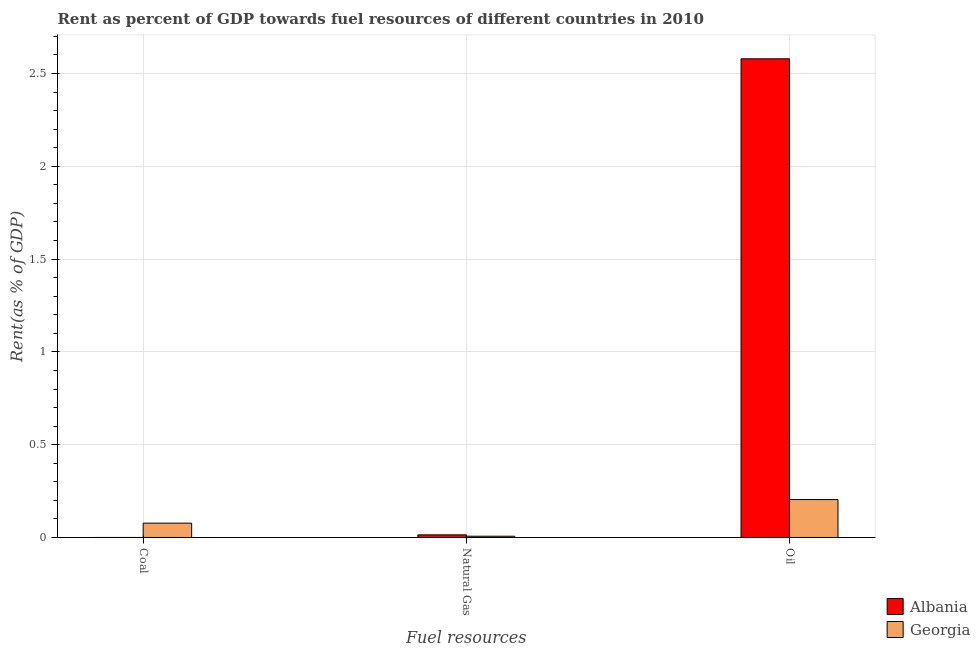How many different coloured bars are there?
Your answer should be very brief. 2. How many groups of bars are there?
Keep it short and to the point. 3. Are the number of bars per tick equal to the number of legend labels?
Your answer should be compact. Yes. Are the number of bars on each tick of the X-axis equal?
Provide a short and direct response. Yes. What is the label of the 1st group of bars from the left?
Offer a terse response. Coal. What is the rent towards oil in Albania?
Provide a succinct answer. 2.58. Across all countries, what is the maximum rent towards natural gas?
Make the answer very short. 0.01. Across all countries, what is the minimum rent towards coal?
Keep it short and to the point. 0. In which country was the rent towards coal maximum?
Offer a very short reply. Georgia. In which country was the rent towards natural gas minimum?
Give a very brief answer. Georgia. What is the total rent towards coal in the graph?
Ensure brevity in your answer.  0.08. What is the difference between the rent towards natural gas in Georgia and that in Albania?
Offer a very short reply. -0.01. What is the difference between the rent towards natural gas in Georgia and the rent towards oil in Albania?
Give a very brief answer. -2.57. What is the average rent towards oil per country?
Give a very brief answer. 1.39. What is the difference between the rent towards oil and rent towards natural gas in Albania?
Offer a terse response. 2.56. In how many countries, is the rent towards coal greater than 2.4 %?
Offer a very short reply. 0. What is the ratio of the rent towards coal in Albania to that in Georgia?
Give a very brief answer. 0. What is the difference between the highest and the second highest rent towards oil?
Keep it short and to the point. 2.37. What is the difference between the highest and the lowest rent towards oil?
Ensure brevity in your answer.  2.37. Is the sum of the rent towards oil in Albania and Georgia greater than the maximum rent towards natural gas across all countries?
Your answer should be very brief. Yes. What does the 2nd bar from the left in Natural Gas represents?
Keep it short and to the point. Georgia. What does the 1st bar from the right in Natural Gas represents?
Keep it short and to the point. Georgia. Is it the case that in every country, the sum of the rent towards coal and rent towards natural gas is greater than the rent towards oil?
Make the answer very short. No. How many bars are there?
Make the answer very short. 6. How many countries are there in the graph?
Your response must be concise. 2. What is the difference between two consecutive major ticks on the Y-axis?
Provide a succinct answer. 0.5. Are the values on the major ticks of Y-axis written in scientific E-notation?
Your response must be concise. No. Does the graph contain any zero values?
Offer a very short reply. No. Does the graph contain grids?
Provide a short and direct response. Yes. How are the legend labels stacked?
Make the answer very short. Vertical. What is the title of the graph?
Provide a short and direct response. Rent as percent of GDP towards fuel resources of different countries in 2010. What is the label or title of the X-axis?
Ensure brevity in your answer.  Fuel resources. What is the label or title of the Y-axis?
Your answer should be very brief. Rent(as % of GDP). What is the Rent(as % of GDP) of Albania in Coal?
Give a very brief answer. 0. What is the Rent(as % of GDP) of Georgia in Coal?
Provide a succinct answer. 0.08. What is the Rent(as % of GDP) of Albania in Natural Gas?
Offer a very short reply. 0.01. What is the Rent(as % of GDP) of Georgia in Natural Gas?
Provide a succinct answer. 0.01. What is the Rent(as % of GDP) in Albania in Oil?
Ensure brevity in your answer.  2.58. What is the Rent(as % of GDP) in Georgia in Oil?
Make the answer very short. 0.2. Across all Fuel resources, what is the maximum Rent(as % of GDP) of Albania?
Provide a succinct answer. 2.58. Across all Fuel resources, what is the maximum Rent(as % of GDP) in Georgia?
Give a very brief answer. 0.2. Across all Fuel resources, what is the minimum Rent(as % of GDP) in Albania?
Your answer should be compact. 0. Across all Fuel resources, what is the minimum Rent(as % of GDP) in Georgia?
Offer a terse response. 0.01. What is the total Rent(as % of GDP) of Albania in the graph?
Your answer should be very brief. 2.59. What is the total Rent(as % of GDP) of Georgia in the graph?
Offer a very short reply. 0.29. What is the difference between the Rent(as % of GDP) of Albania in Coal and that in Natural Gas?
Offer a very short reply. -0.01. What is the difference between the Rent(as % of GDP) in Georgia in Coal and that in Natural Gas?
Offer a terse response. 0.07. What is the difference between the Rent(as % of GDP) of Albania in Coal and that in Oil?
Keep it short and to the point. -2.58. What is the difference between the Rent(as % of GDP) of Georgia in Coal and that in Oil?
Provide a succinct answer. -0.13. What is the difference between the Rent(as % of GDP) in Albania in Natural Gas and that in Oil?
Your response must be concise. -2.56. What is the difference between the Rent(as % of GDP) in Georgia in Natural Gas and that in Oil?
Provide a succinct answer. -0.2. What is the difference between the Rent(as % of GDP) of Albania in Coal and the Rent(as % of GDP) of Georgia in Natural Gas?
Your answer should be compact. -0.01. What is the difference between the Rent(as % of GDP) of Albania in Coal and the Rent(as % of GDP) of Georgia in Oil?
Your answer should be very brief. -0.2. What is the difference between the Rent(as % of GDP) in Albania in Natural Gas and the Rent(as % of GDP) in Georgia in Oil?
Make the answer very short. -0.19. What is the average Rent(as % of GDP) in Albania per Fuel resources?
Your answer should be compact. 0.86. What is the average Rent(as % of GDP) of Georgia per Fuel resources?
Give a very brief answer. 0.1. What is the difference between the Rent(as % of GDP) in Albania and Rent(as % of GDP) in Georgia in Coal?
Your answer should be compact. -0.08. What is the difference between the Rent(as % of GDP) of Albania and Rent(as % of GDP) of Georgia in Natural Gas?
Give a very brief answer. 0.01. What is the difference between the Rent(as % of GDP) in Albania and Rent(as % of GDP) in Georgia in Oil?
Your response must be concise. 2.37. What is the ratio of the Rent(as % of GDP) of Albania in Coal to that in Natural Gas?
Your answer should be very brief. 0.01. What is the ratio of the Rent(as % of GDP) in Georgia in Coal to that in Natural Gas?
Offer a very short reply. 11.43. What is the ratio of the Rent(as % of GDP) in Georgia in Coal to that in Oil?
Provide a succinct answer. 0.38. What is the ratio of the Rent(as % of GDP) in Albania in Natural Gas to that in Oil?
Provide a succinct answer. 0.01. What is the ratio of the Rent(as % of GDP) in Georgia in Natural Gas to that in Oil?
Provide a succinct answer. 0.03. What is the difference between the highest and the second highest Rent(as % of GDP) in Albania?
Provide a short and direct response. 2.56. What is the difference between the highest and the second highest Rent(as % of GDP) of Georgia?
Give a very brief answer. 0.13. What is the difference between the highest and the lowest Rent(as % of GDP) of Albania?
Your answer should be compact. 2.58. What is the difference between the highest and the lowest Rent(as % of GDP) of Georgia?
Make the answer very short. 0.2. 